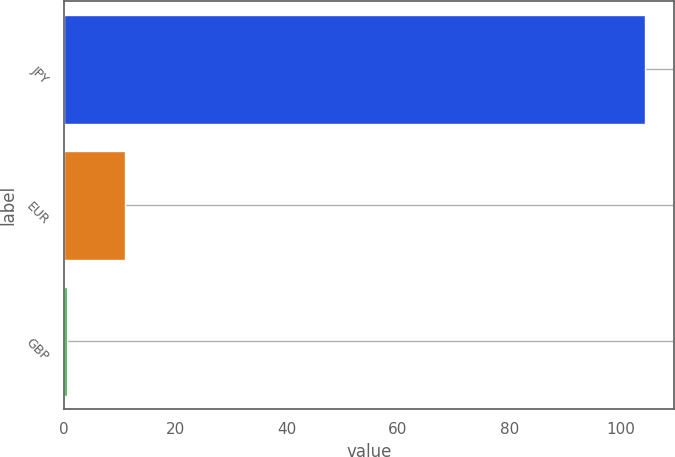<chart> <loc_0><loc_0><loc_500><loc_500><bar_chart><fcel>JPY<fcel>EUR<fcel>GBP<nl><fcel>104.43<fcel>10.99<fcel>0.61<nl></chart> 